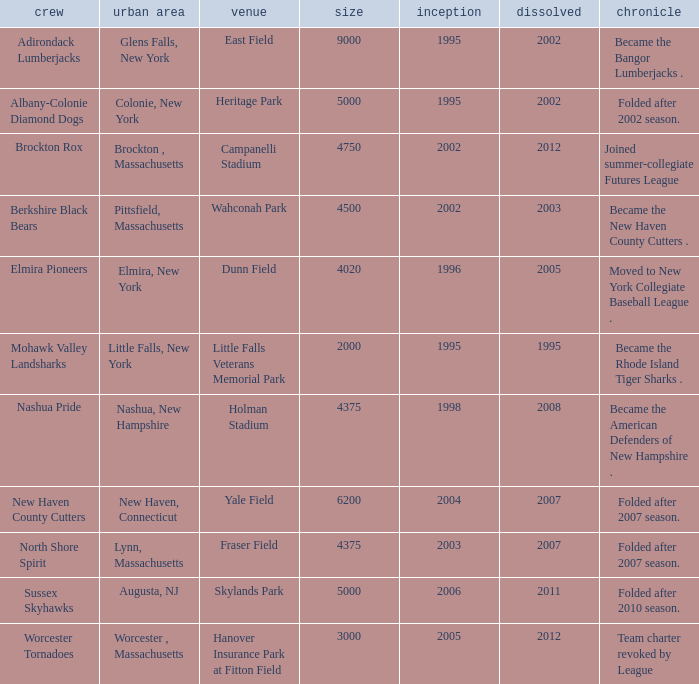What is the maximum folded value of the team whose stadium is Fraser Field? 2007.0. 